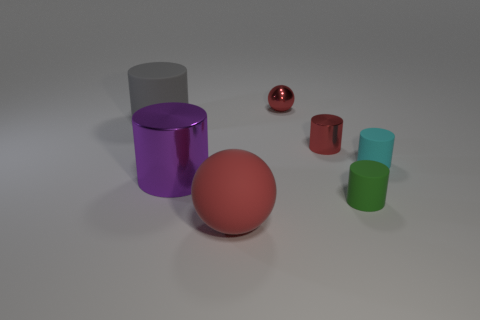There is another sphere that is the same color as the matte ball; what is its size?
Ensure brevity in your answer.  Small. How many objects are either gray objects that are left of the cyan matte cylinder or rubber cylinders on the right side of the big gray rubber cylinder?
Your answer should be compact. 3. Are there any red things of the same size as the purple metallic cylinder?
Offer a very short reply. Yes. What is the color of the other small rubber thing that is the same shape as the cyan object?
Provide a succinct answer. Green. There is a big matte thing left of the purple shiny object; are there any large gray cylinders that are behind it?
Your answer should be compact. No. There is a red thing that is to the right of the tiny red metallic sphere; is its shape the same as the large shiny object?
Provide a succinct answer. Yes. What is the shape of the gray object?
Keep it short and to the point. Cylinder. What number of small green cylinders are the same material as the small cyan cylinder?
Your answer should be very brief. 1. There is a tiny shiny cylinder; is it the same color as the sphere behind the tiny cyan rubber thing?
Ensure brevity in your answer.  Yes. How many tiny rubber balls are there?
Offer a terse response. 0. 